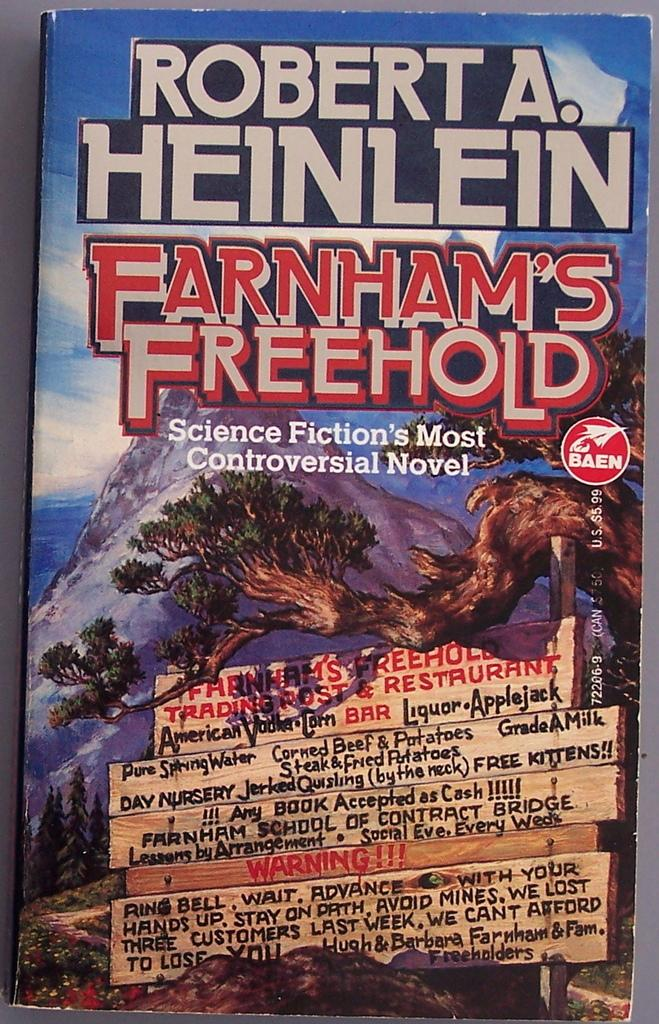<image>
Render a clear and concise summary of the photo. the top of a book that says 'robert a. heinlein' on it 